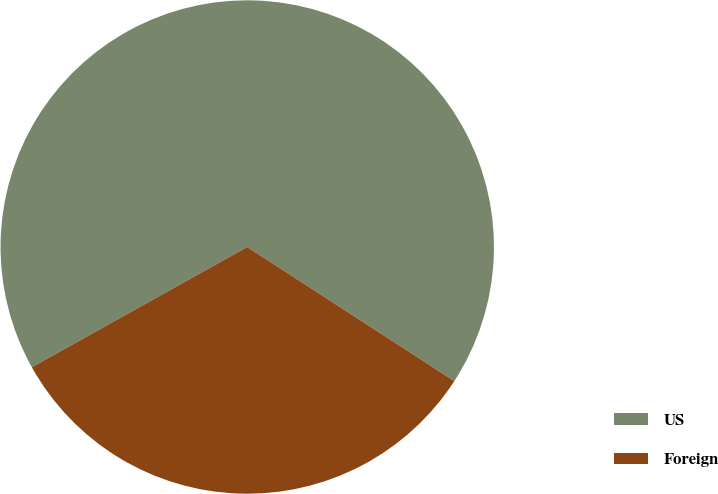Convert chart to OTSL. <chart><loc_0><loc_0><loc_500><loc_500><pie_chart><fcel>US<fcel>Foreign<nl><fcel>67.25%<fcel>32.75%<nl></chart> 